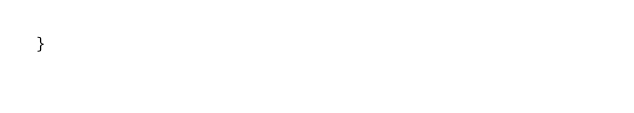Convert code to text. <code><loc_0><loc_0><loc_500><loc_500><_CSS_>}
</code> 